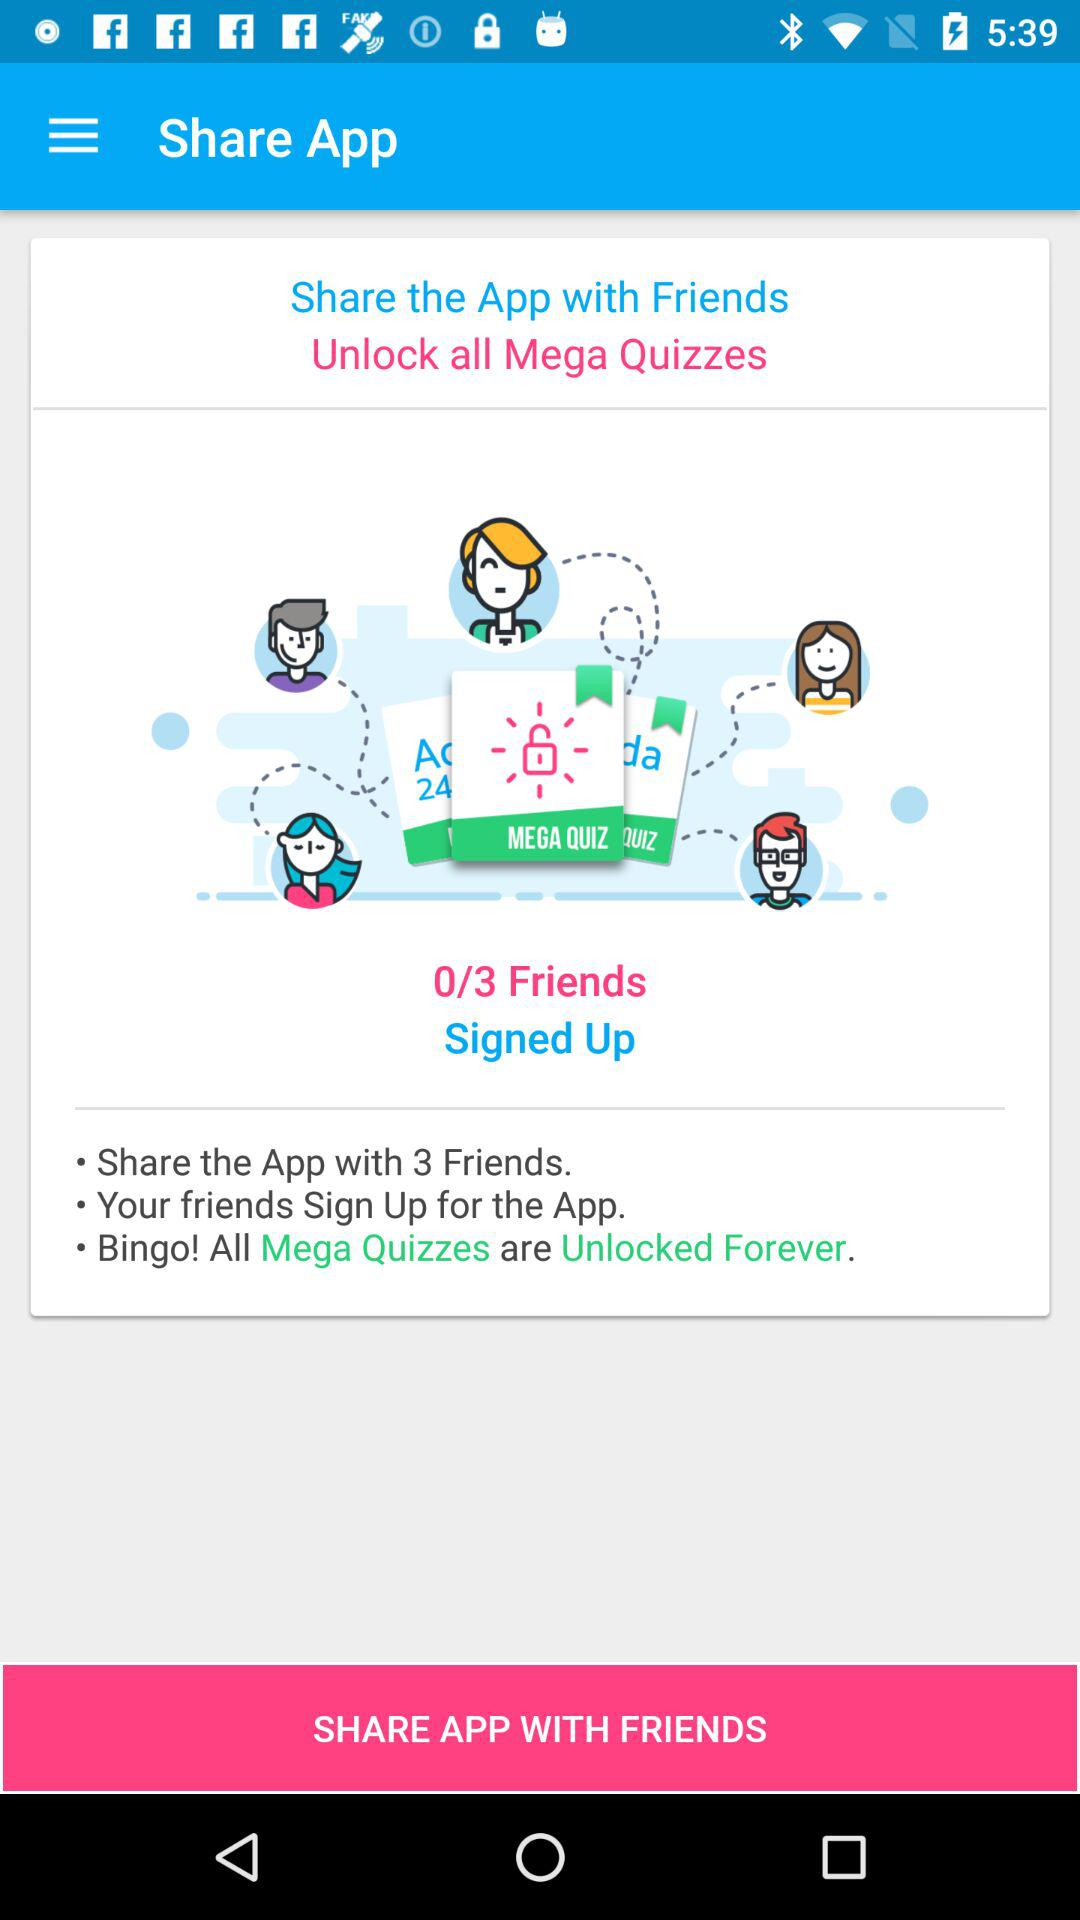How many more friends do I need to sign up to unlock all mega quizzes?
Answer the question using a single word or phrase. 3 